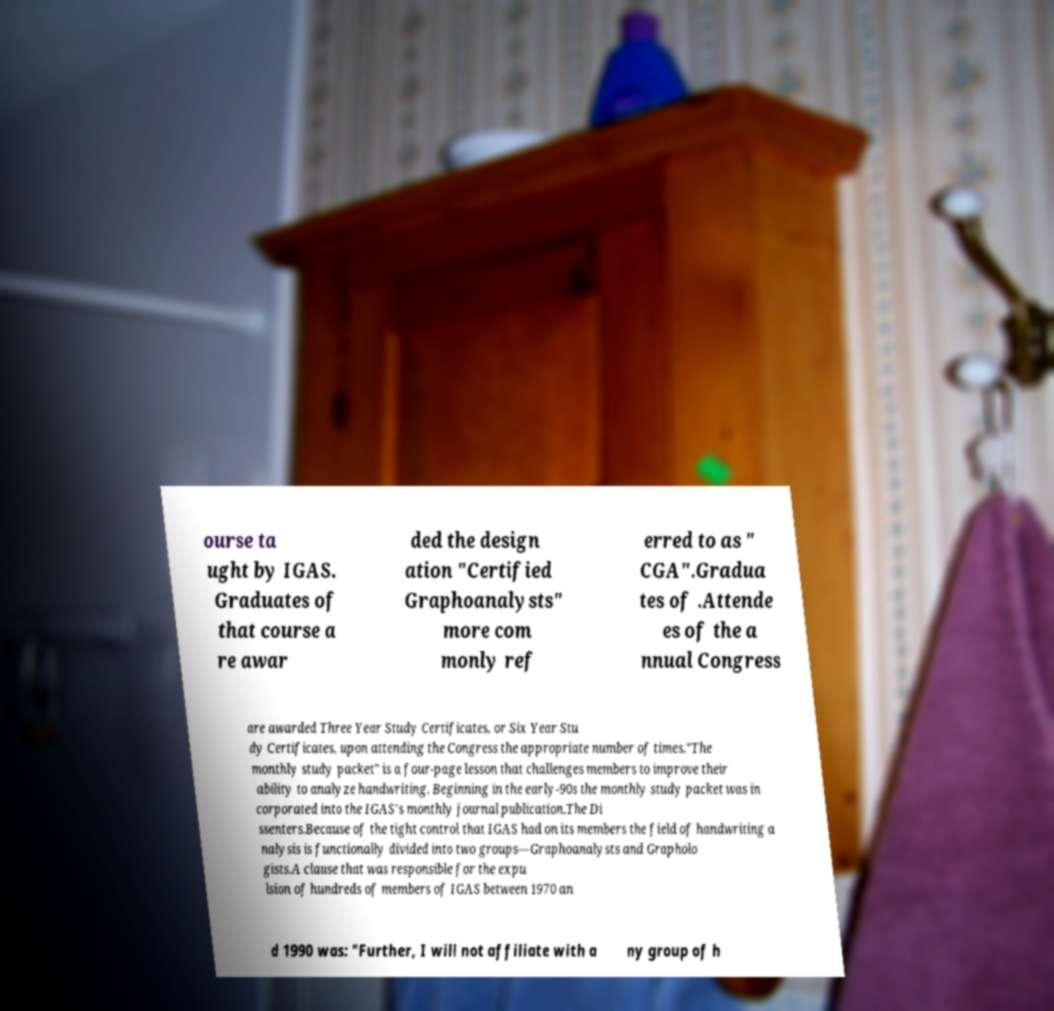Can you accurately transcribe the text from the provided image for me? ourse ta ught by IGAS. Graduates of that course a re awar ded the design ation "Certified Graphoanalysts" more com monly ref erred to as " CGA".Gradua tes of .Attende es of the a nnual Congress are awarded Three Year Study Certificates, or Six Year Stu dy Certificates, upon attending the Congress the appropriate number of times."The monthly study packet" is a four-page lesson that challenges members to improve their ability to analyze handwriting. Beginning in the early-90s the monthly study packet was in corporated into the IGAS's monthly journal publication.The Di ssenters.Because of the tight control that IGAS had on its members the field of handwriting a nalysis is functionally divided into two groups—Graphoanalysts and Grapholo gists.A clause that was responsible for the expu lsion of hundreds of members of IGAS between 1970 an d 1990 was: "Further, I will not affiliate with a ny group of h 